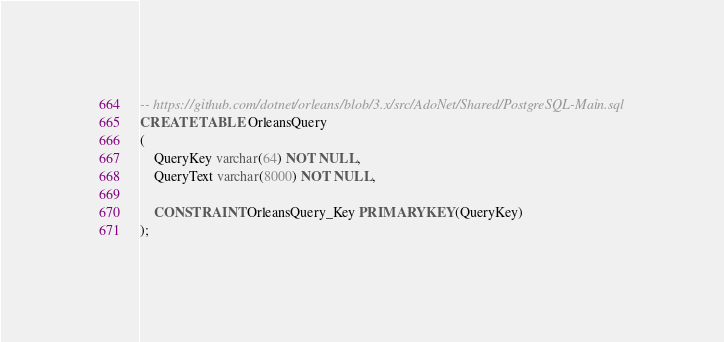Convert code to text. <code><loc_0><loc_0><loc_500><loc_500><_SQL_>-- https://github.com/dotnet/orleans/blob/3.x/src/AdoNet/Shared/PostgreSQL-Main.sql
CREATE TABLE OrleansQuery
(
    QueryKey varchar(64) NOT NULL,
    QueryText varchar(8000) NOT NULL,

    CONSTRAINT OrleansQuery_Key PRIMARY KEY(QueryKey)
);
</code> 